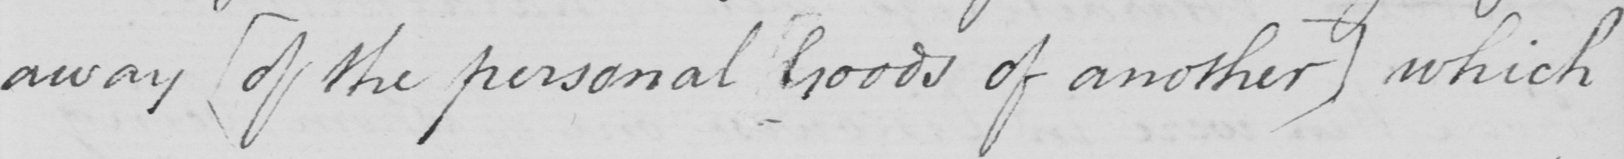Please transcribe the handwritten text in this image. away  [ of the personal goods of another ]  which 